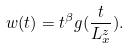Convert formula to latex. <formula><loc_0><loc_0><loc_500><loc_500>w ( t ) = t ^ { \beta } g ( \frac { t } { L _ { x } ^ { z } } ) .</formula> 